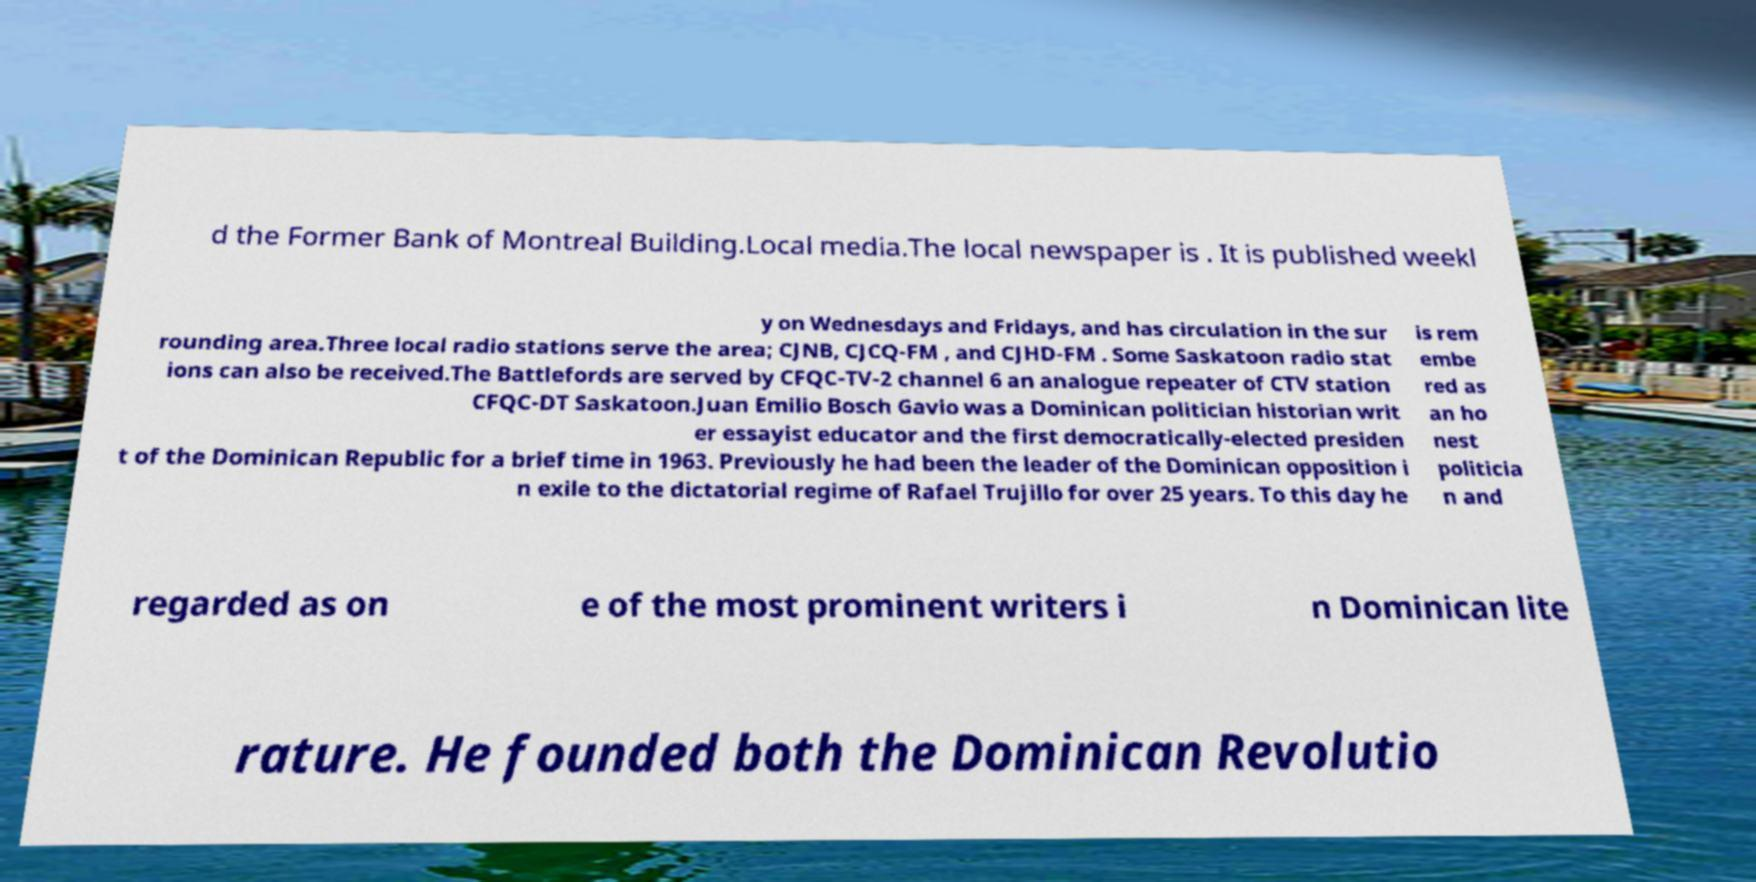What messages or text are displayed in this image? I need them in a readable, typed format. d the Former Bank of Montreal Building.Local media.The local newspaper is . It is published weekl y on Wednesdays and Fridays, and has circulation in the sur rounding area.Three local radio stations serve the area; CJNB, CJCQ-FM , and CJHD-FM . Some Saskatoon radio stat ions can also be received.The Battlefords are served by CFQC-TV-2 channel 6 an analogue repeater of CTV station CFQC-DT Saskatoon.Juan Emilio Bosch Gavio was a Dominican politician historian writ er essayist educator and the first democratically-elected presiden t of the Dominican Republic for a brief time in 1963. Previously he had been the leader of the Dominican opposition i n exile to the dictatorial regime of Rafael Trujillo for over 25 years. To this day he is rem embe red as an ho nest politicia n and regarded as on e of the most prominent writers i n Dominican lite rature. He founded both the Dominican Revolutio 